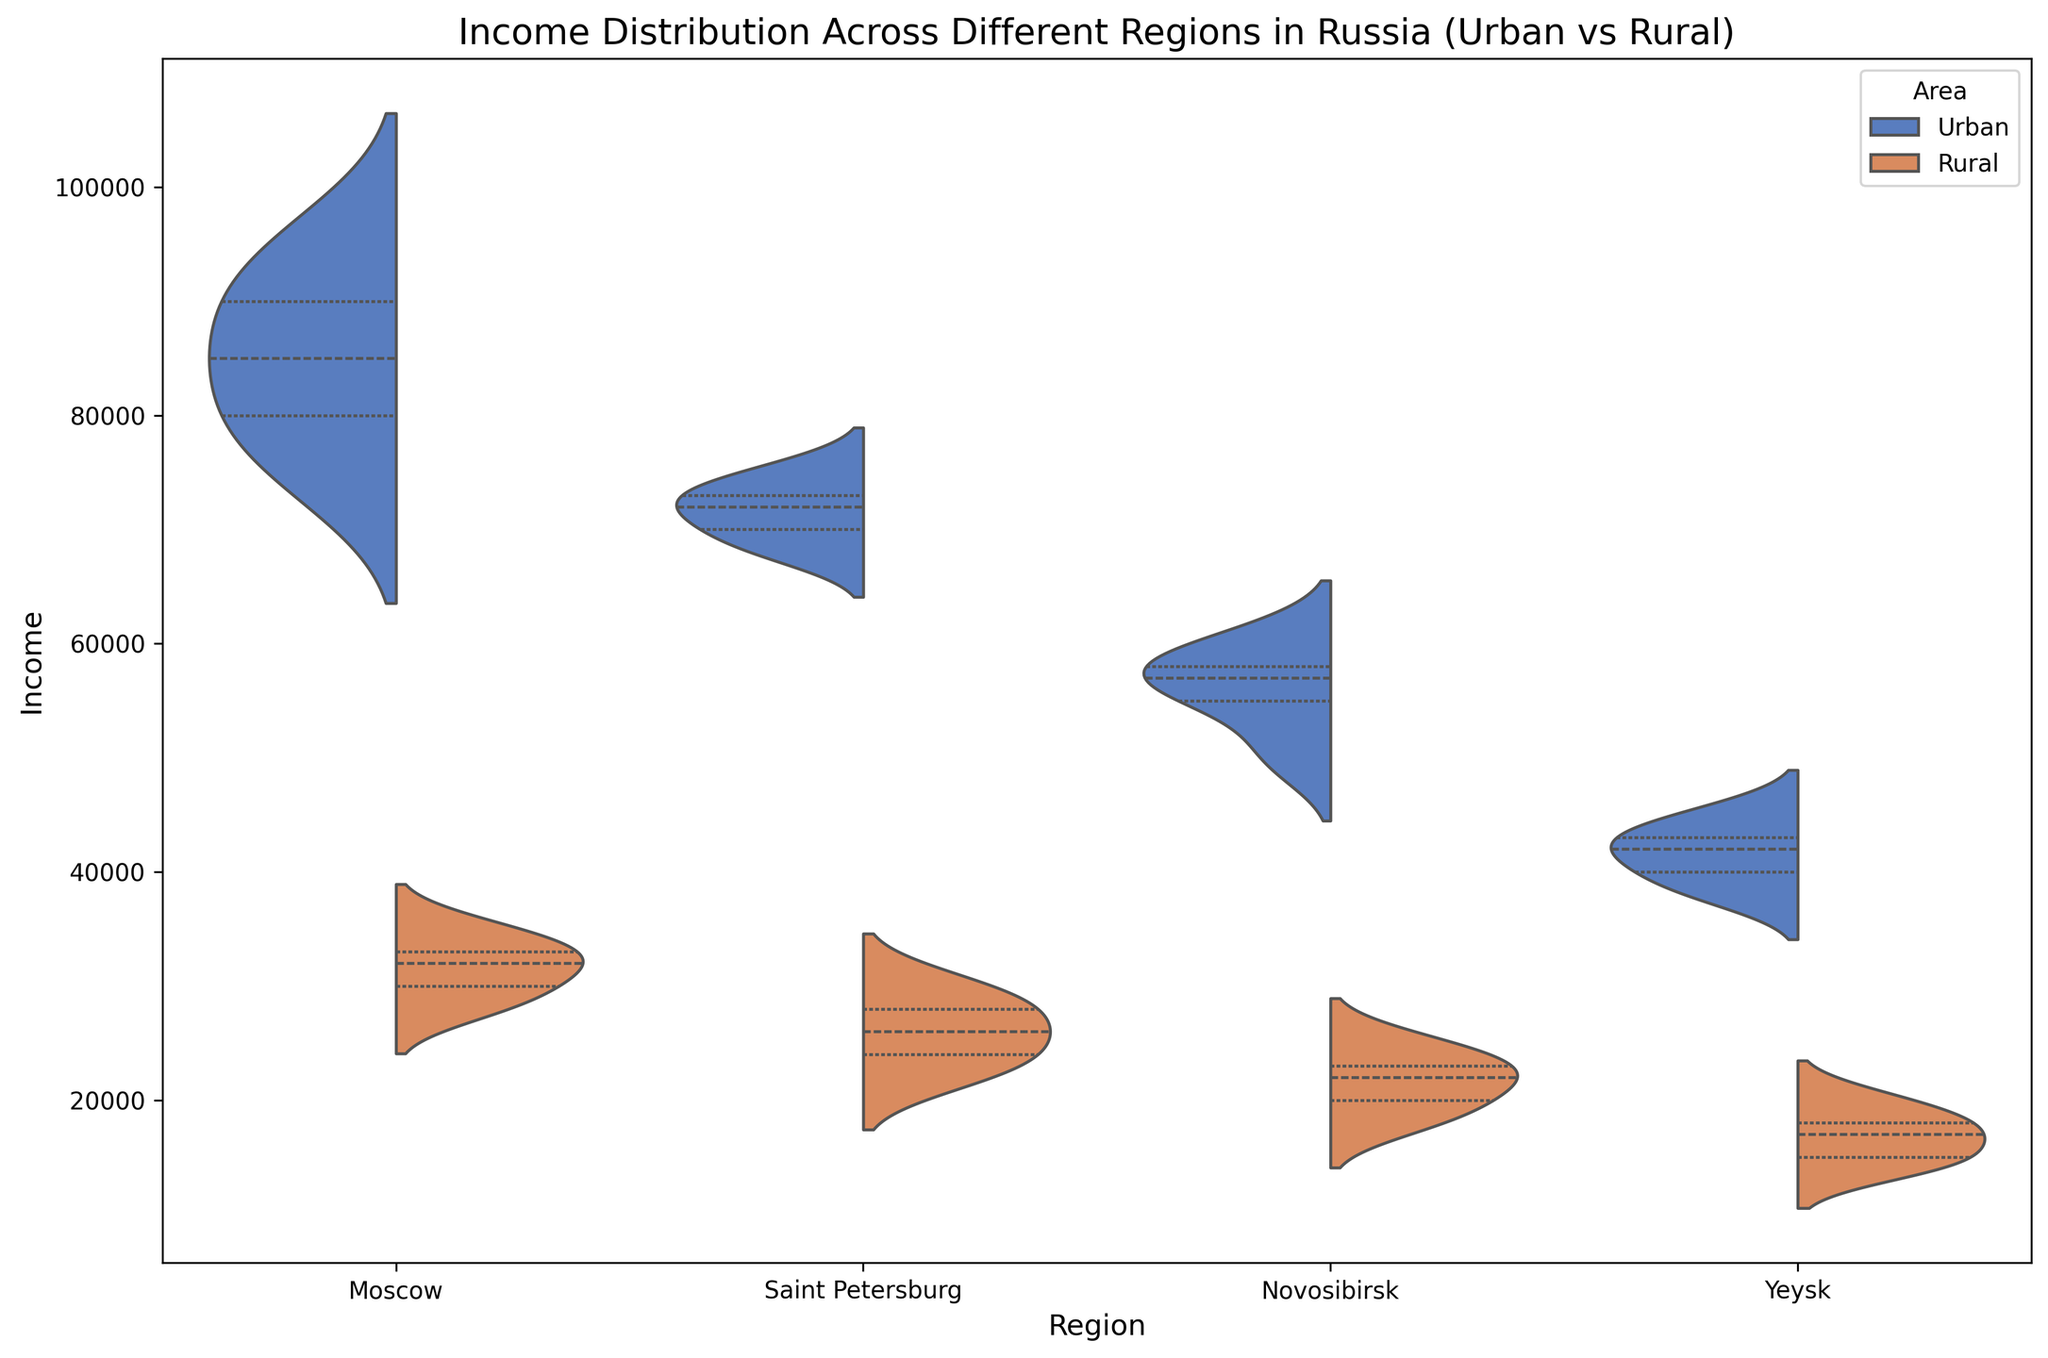What are the general trends in income between urban and rural areas across the regions? Urban areas generally show higher income distributions compared to rural areas within each region. For example, Moscow's urban area has higher income levels compared to its rural area. Similarly, other regions like Saint Petersburg, Novosibirsk, and Yeysk also display higher incomes in urban areas than rural areas. This pattern is consistent throughout the figure.
Answer: Urban areas have higher incomes Which region shows the highest income for urban areas? By observing the highest points in the urban areas of each region, it is clear that Moscow has the highest income for urban areas. The top whisker of Moscow's urban area is higher than those of Saint Petersburg, Novosibirsk, and Yeysk.
Answer: Moscow How does the income distribution in rural Yeysk compare to rural Novosibirsk? The violin plot indicates that the income distribution in rural Yeysk is generally lower than in rural Novosibirsk. The median and the interquartile range for rural Yeysk are lower compared to rural Novosibirsk.
Answer: Lower Which region has the most significant difference between urban and rural incomes? To determine this, we compare the range of incomes in urban and rural areas for each region. Moscow shows the most significant difference, with urban incomes ranging much higher than rural incomes. Saint Petersburg shows a smaller difference, and Yeysk shows the least difference.
Answer: Moscow What is the overall pattern of income distribution in Saint Petersburg? Saint Petersburg shows a clear distinction between urban and rural areas. Urban incomes are higher and more concentrated around the median, whereas rural incomes are lower and show a wider spread in the distribution.
Answer: Urban higher, rural lower Which area has the widest spread of income in Yeysk? By observing the width of the violin plots, Yeysk's rural area shows a wider spread of income distribution compared to the urban area. The rural plot is wider at the interquartile range.
Answer: Rural In which region does the rural area show the highest income distribution? Observing the peaks and spread of the rural area violin plots, Moscow's rural income distribution is higher compared to the other regions' rural areas. The median and interquartile range are higher as well.
Answer: Moscow How do incomes in urban Novosibirsk compare to urban Yeysk? Urban Novosibirsk has higher incomes compared to urban Yeysk. The median and the highest points in the distribution for Novosibirsk are above those for Yeysk.
Answer: Higher What can we infer about economic disparities in these regions from the plot? The plot indicates significant economic disparities between urban and rural areas within each region. Urban areas consistently have higher incomes, suggesting better economic opportunities. Moscow, especially, shows a substantial income gap between urban and rural. These trends can highlight the need for targeted interventions in rural areas to reduce economic disparities.
Answer: Significant disparities 